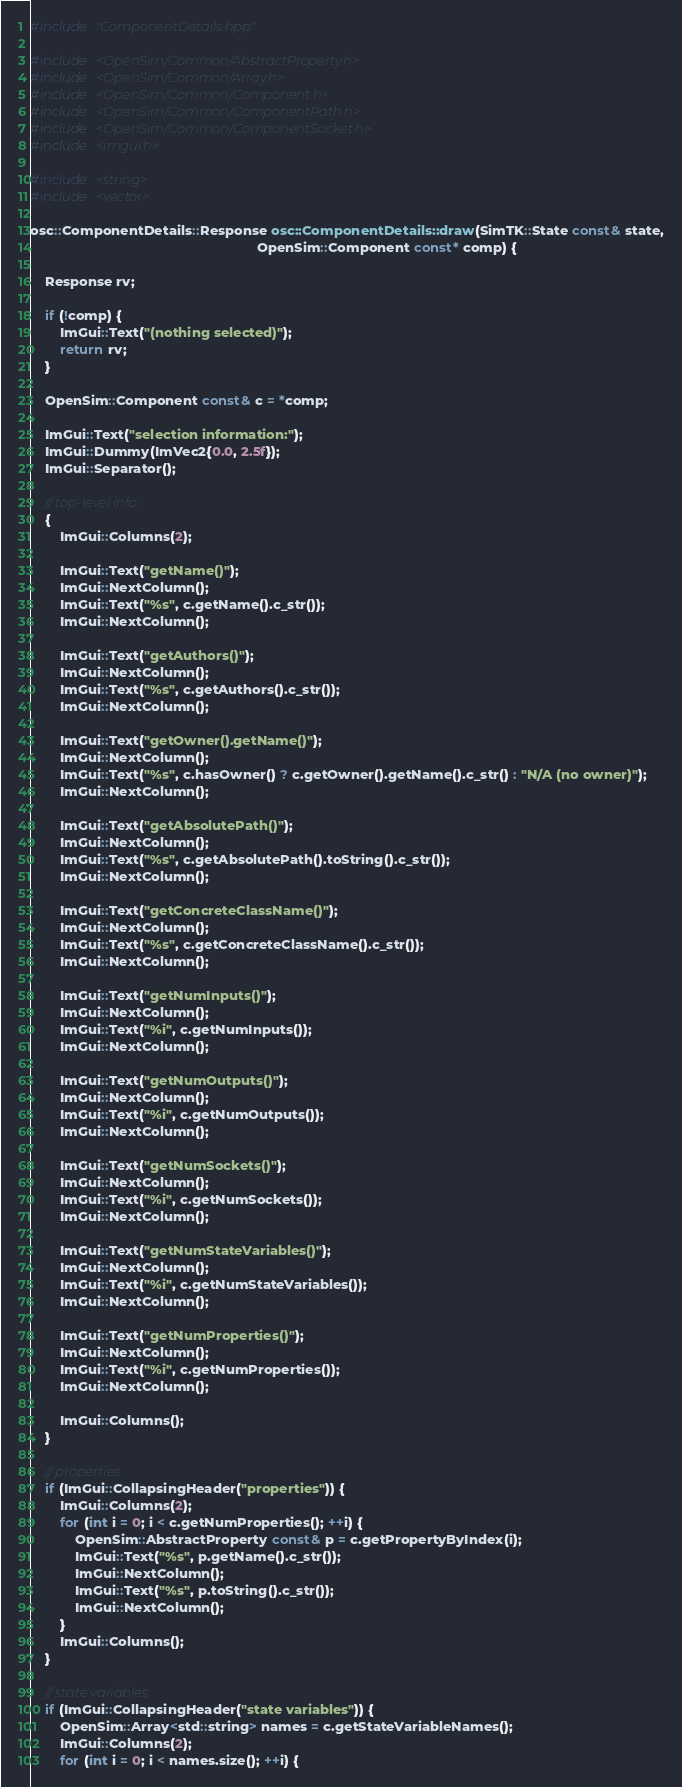<code> <loc_0><loc_0><loc_500><loc_500><_C++_>#include "ComponentDetails.hpp"

#include <OpenSim/Common/AbstractProperty.h>
#include <OpenSim/Common/Array.h>
#include <OpenSim/Common/Component.h>
#include <OpenSim/Common/ComponentPath.h>
#include <OpenSim/Common/ComponentSocket.h>
#include <imgui.h>

#include <string>
#include <vector>

osc::ComponentDetails::Response osc::ComponentDetails::draw(SimTK::State const& state,
                                                            OpenSim::Component const* comp) {

    Response rv;

    if (!comp) {
        ImGui::Text("(nothing selected)");
        return rv;
    }

    OpenSim::Component const& c = *comp;

    ImGui::Text("selection information:");
    ImGui::Dummy(ImVec2{0.0, 2.5f});
    ImGui::Separator();

    // top-level info
    {
        ImGui::Columns(2);

        ImGui::Text("getName()");
        ImGui::NextColumn();
        ImGui::Text("%s", c.getName().c_str());
        ImGui::NextColumn();

        ImGui::Text("getAuthors()");
        ImGui::NextColumn();
        ImGui::Text("%s", c.getAuthors().c_str());
        ImGui::NextColumn();

        ImGui::Text("getOwner().getName()");
        ImGui::NextColumn();
        ImGui::Text("%s", c.hasOwner() ? c.getOwner().getName().c_str() : "N/A (no owner)");
        ImGui::NextColumn();

        ImGui::Text("getAbsolutePath()");
        ImGui::NextColumn();
        ImGui::Text("%s", c.getAbsolutePath().toString().c_str());
        ImGui::NextColumn();

        ImGui::Text("getConcreteClassName()");
        ImGui::NextColumn();
        ImGui::Text("%s", c.getConcreteClassName().c_str());
        ImGui::NextColumn();

        ImGui::Text("getNumInputs()");
        ImGui::NextColumn();
        ImGui::Text("%i", c.getNumInputs());
        ImGui::NextColumn();

        ImGui::Text("getNumOutputs()");
        ImGui::NextColumn();
        ImGui::Text("%i", c.getNumOutputs());
        ImGui::NextColumn();

        ImGui::Text("getNumSockets()");
        ImGui::NextColumn();
        ImGui::Text("%i", c.getNumSockets());
        ImGui::NextColumn();

        ImGui::Text("getNumStateVariables()");
        ImGui::NextColumn();
        ImGui::Text("%i", c.getNumStateVariables());
        ImGui::NextColumn();

        ImGui::Text("getNumProperties()");
        ImGui::NextColumn();
        ImGui::Text("%i", c.getNumProperties());
        ImGui::NextColumn();

        ImGui::Columns();
    }

    // properties
    if (ImGui::CollapsingHeader("properties")) {
        ImGui::Columns(2);
        for (int i = 0; i < c.getNumProperties(); ++i) {
            OpenSim::AbstractProperty const& p = c.getPropertyByIndex(i);
            ImGui::Text("%s", p.getName().c_str());
            ImGui::NextColumn();
            ImGui::Text("%s", p.toString().c_str());
            ImGui::NextColumn();
        }
        ImGui::Columns();
    }

    // state variables
    if (ImGui::CollapsingHeader("state variables")) {
        OpenSim::Array<std::string> names = c.getStateVariableNames();
        ImGui::Columns(2);
        for (int i = 0; i < names.size(); ++i) {</code> 